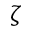Convert formula to latex. <formula><loc_0><loc_0><loc_500><loc_500>\zeta</formula> 